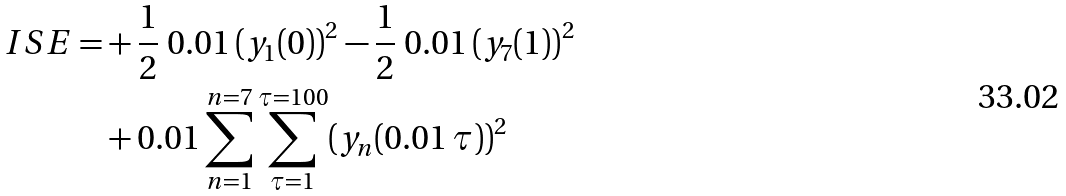Convert formula to latex. <formula><loc_0><loc_0><loc_500><loc_500>I S E = & + \frac { 1 } { 2 } \ 0 . 0 1 \, ( y _ { 1 } ( 0 ) ) ^ { 2 } - \frac { 1 } { 2 } \ 0 . 0 1 \, ( y _ { 7 } ( 1 ) ) ^ { 2 } \\ & + 0 . 0 1 \sum _ { n = 1 } ^ { n = 7 } \sum _ { \tau = 1 } ^ { \tau = 1 0 0 } ( y _ { n } ( 0 . 0 1 \, \tau ) ) ^ { 2 } \\</formula> 